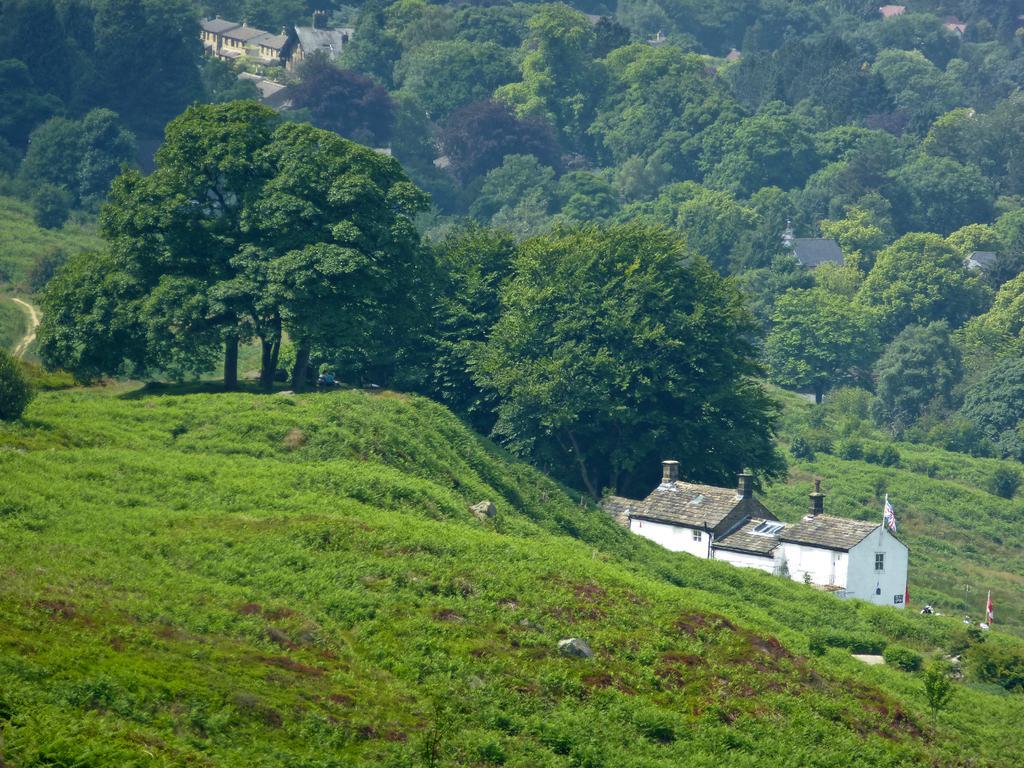How would you summarize this image in a sentence or two? In this picture we can see grass, flags, buildings with windows and in the background we can see trees. 